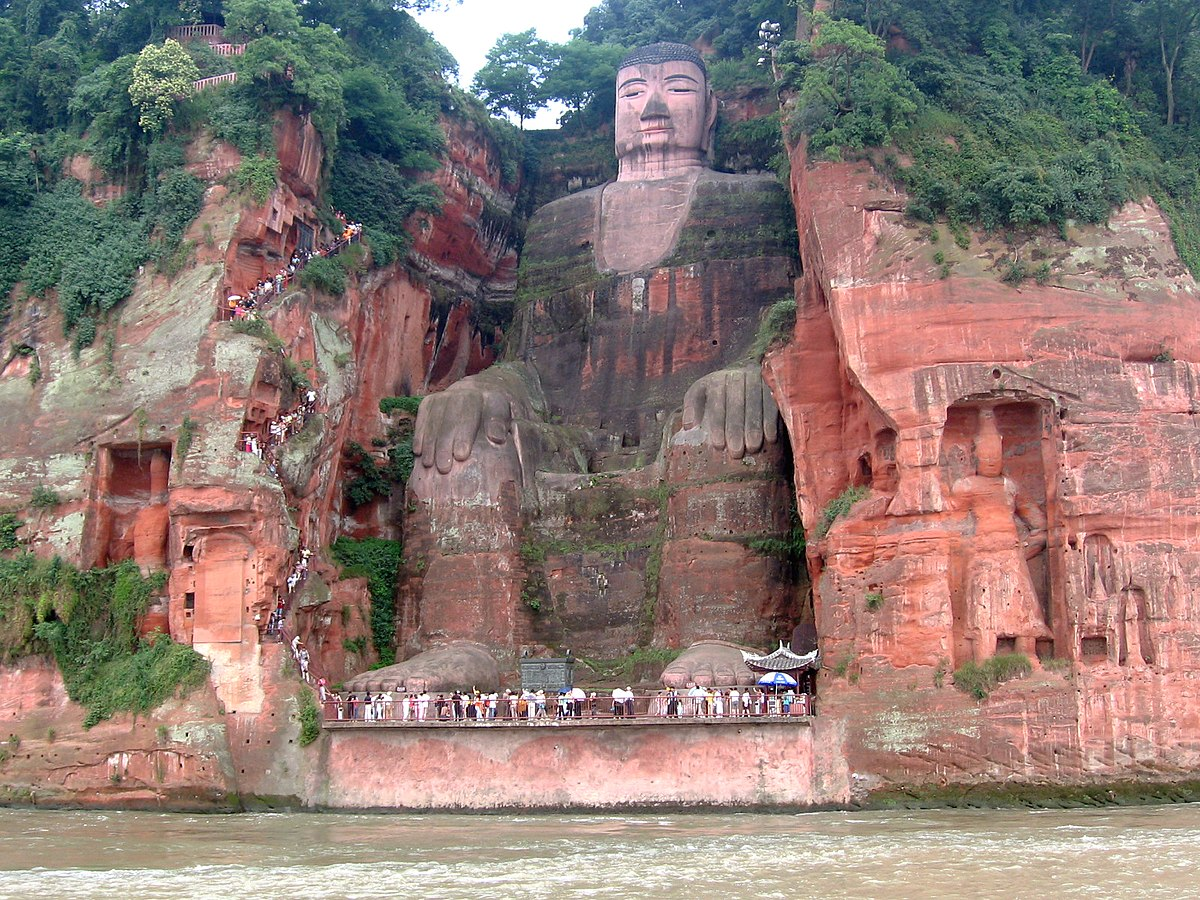Can you tell more about the significance of the Leshan Giant Buddha for local culture? Certainly! The Leshan Giant Buddha is deeply entrenched in Chinese spiritual and cultural history. Originally built to placate the spirits believed to cause the turbulent river waters that plagued shipping vessels, it stands as a guardian symbol. Locally, it represents benevolence and wisdom, reflecting Buddhist values deeply interwoven into Sichuan's cultural fabric. It’s not just a religious monument but also a testament to communal effort and a focal point for local festivals and rituals, primarily drawing tourism and promoting economic development in the region. 